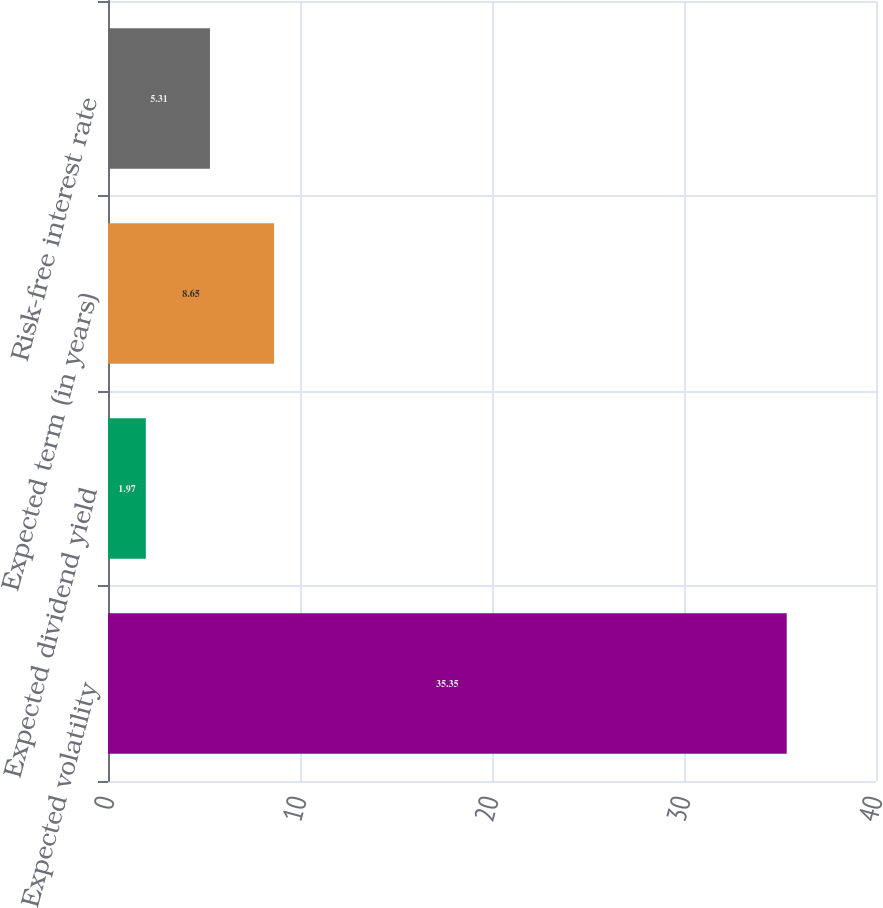Convert chart. <chart><loc_0><loc_0><loc_500><loc_500><bar_chart><fcel>Expected volatility<fcel>Expected dividend yield<fcel>Expected term (in years)<fcel>Risk-free interest rate<nl><fcel>35.35<fcel>1.97<fcel>8.65<fcel>5.31<nl></chart> 